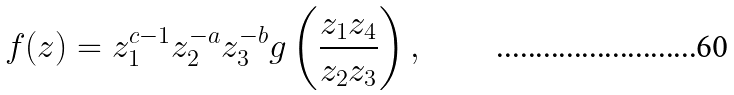<formula> <loc_0><loc_0><loc_500><loc_500>f ( z ) = z _ { 1 } ^ { c - 1 } z _ { 2 } ^ { - a } z _ { 3 } ^ { - b } g \left ( \frac { z _ { 1 } z _ { 4 } } { z _ { 2 } z _ { 3 } } \right ) ,</formula> 